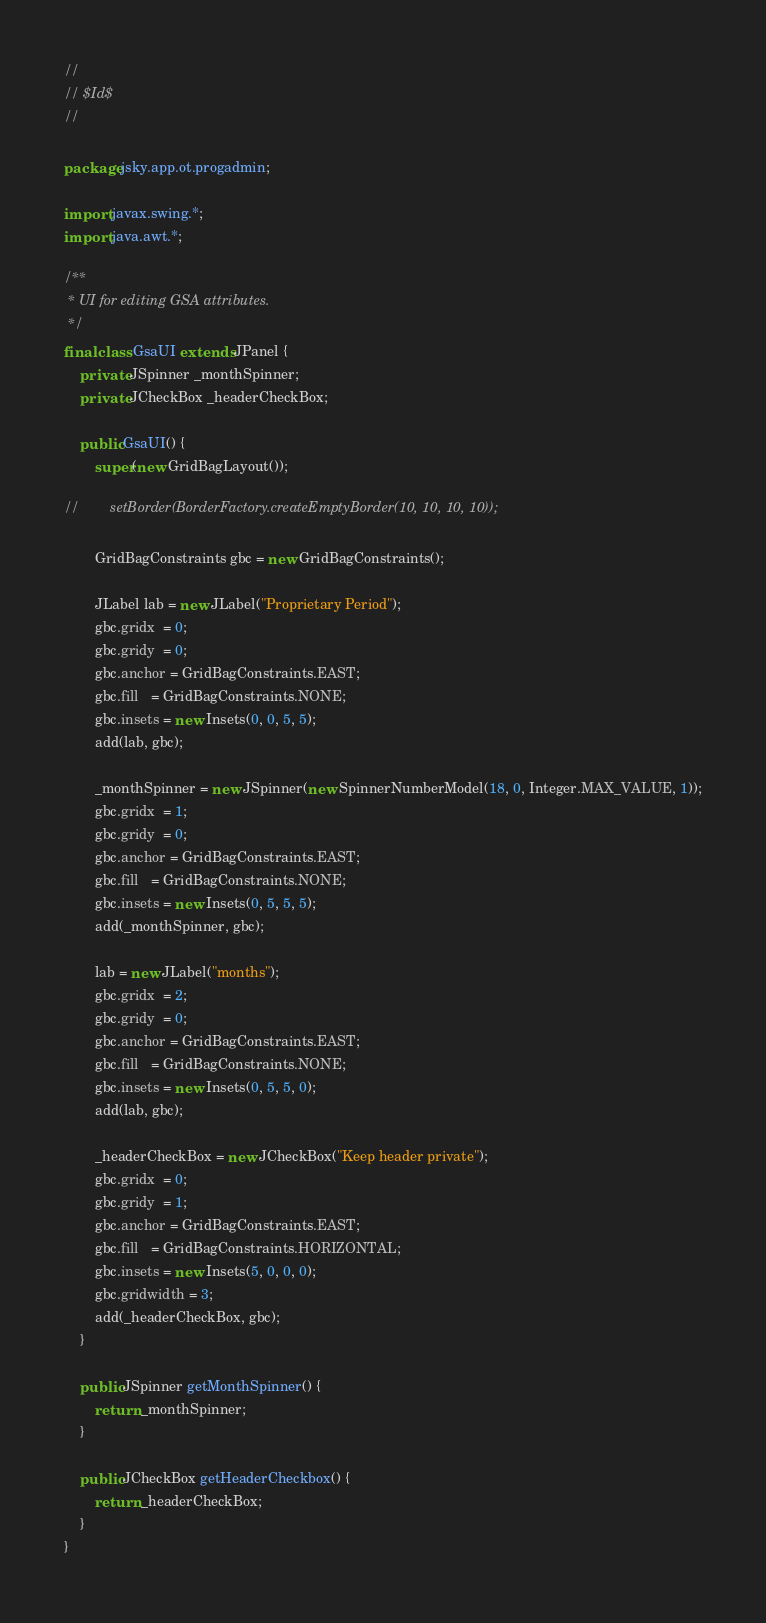Convert code to text. <code><loc_0><loc_0><loc_500><loc_500><_Java_>//
// $Id$
//

package jsky.app.ot.progadmin;

import javax.swing.*;
import java.awt.*;

/**
 * UI for editing GSA attributes.
 */
final class GsaUI extends JPanel {
    private JSpinner _monthSpinner;
    private JCheckBox _headerCheckBox;

    public GsaUI() {
        super(new GridBagLayout());

//        setBorder(BorderFactory.createEmptyBorder(10, 10, 10, 10));

        GridBagConstraints gbc = new GridBagConstraints();

        JLabel lab = new JLabel("Proprietary Period");
        gbc.gridx  = 0;
        gbc.gridy  = 0;
        gbc.anchor = GridBagConstraints.EAST;
        gbc.fill   = GridBagConstraints.NONE;
        gbc.insets = new Insets(0, 0, 5, 5);
        add(lab, gbc);

        _monthSpinner = new JSpinner(new SpinnerNumberModel(18, 0, Integer.MAX_VALUE, 1));
        gbc.gridx  = 1;
        gbc.gridy  = 0;
        gbc.anchor = GridBagConstraints.EAST;
        gbc.fill   = GridBagConstraints.NONE;
        gbc.insets = new Insets(0, 5, 5, 5);
        add(_monthSpinner, gbc);

        lab = new JLabel("months");
        gbc.gridx  = 2;
        gbc.gridy  = 0;
        gbc.anchor = GridBagConstraints.EAST;
        gbc.fill   = GridBagConstraints.NONE;
        gbc.insets = new Insets(0, 5, 5, 0);
        add(lab, gbc);

        _headerCheckBox = new JCheckBox("Keep header private");
        gbc.gridx  = 0;
        gbc.gridy  = 1;
        gbc.anchor = GridBagConstraints.EAST;
        gbc.fill   = GridBagConstraints.HORIZONTAL;
        gbc.insets = new Insets(5, 0, 0, 0);
        gbc.gridwidth = 3;
        add(_headerCheckBox, gbc);
    }

    public JSpinner getMonthSpinner() {
        return _monthSpinner;
    }

    public JCheckBox getHeaderCheckbox() {
        return _headerCheckBox;
    }
}
</code> 